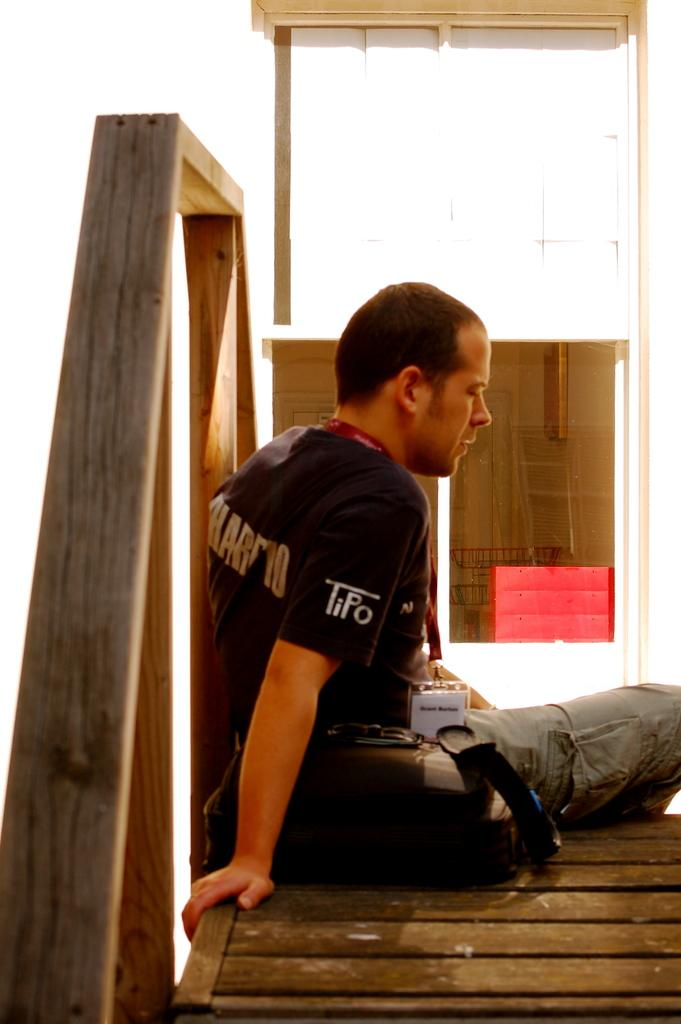What is the person in the image doing? The person is sitting on a bench in the image. What object does the person have with them? The person has a bag with them. What can be seen in the background of the image? There is an object in the background that is red in color, and there is also a wall. What memory does the person have about the red object in the image? There is no indication in the image that the person has any memory or association with the red object. 